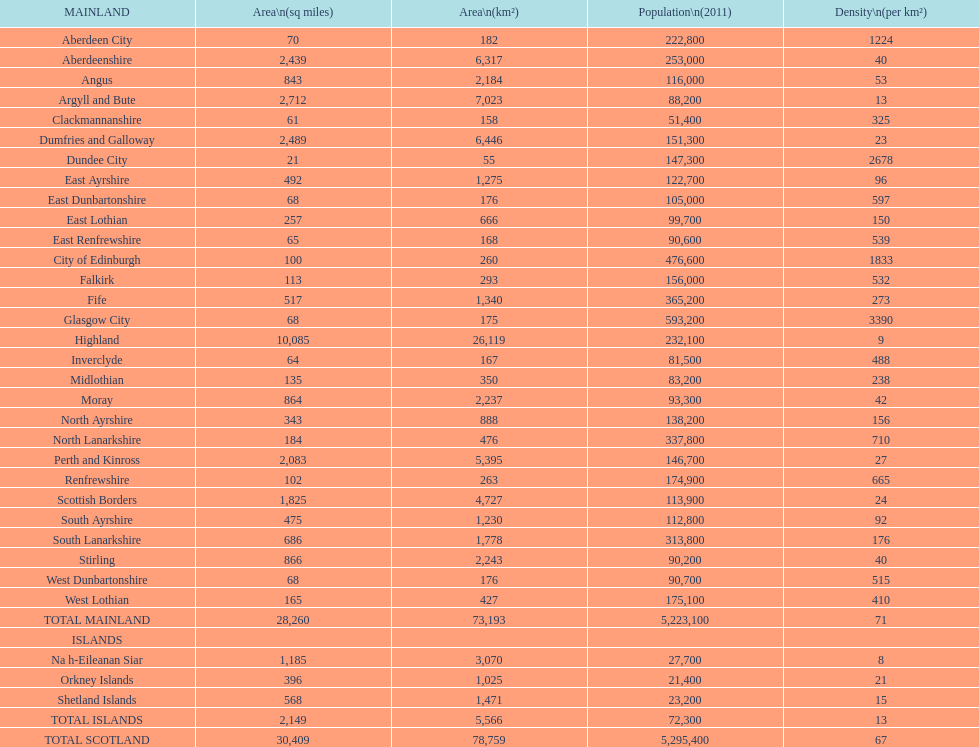Could you parse the entire table as a dict? {'header': ['MAINLAND', 'Area\\n(sq miles)', 'Area\\n(km²)', 'Population\\n(2011)', 'Density\\n(per km²)'], 'rows': [['Aberdeen City', '70', '182', '222,800', '1224'], ['Aberdeenshire', '2,439', '6,317', '253,000', '40'], ['Angus', '843', '2,184', '116,000', '53'], ['Argyll and Bute', '2,712', '7,023', '88,200', '13'], ['Clackmannanshire', '61', '158', '51,400', '325'], ['Dumfries and Galloway', '2,489', '6,446', '151,300', '23'], ['Dundee City', '21', '55', '147,300', '2678'], ['East Ayrshire', '492', '1,275', '122,700', '96'], ['East Dunbartonshire', '68', '176', '105,000', '597'], ['East Lothian', '257', '666', '99,700', '150'], ['East Renfrewshire', '65', '168', '90,600', '539'], ['City of Edinburgh', '100', '260', '476,600', '1833'], ['Falkirk', '113', '293', '156,000', '532'], ['Fife', '517', '1,340', '365,200', '273'], ['Glasgow City', '68', '175', '593,200', '3390'], ['Highland', '10,085', '26,119', '232,100', '9'], ['Inverclyde', '64', '167', '81,500', '488'], ['Midlothian', '135', '350', '83,200', '238'], ['Moray', '864', '2,237', '93,300', '42'], ['North Ayrshire', '343', '888', '138,200', '156'], ['North Lanarkshire', '184', '476', '337,800', '710'], ['Perth and Kinross', '2,083', '5,395', '146,700', '27'], ['Renfrewshire', '102', '263', '174,900', '665'], ['Scottish Borders', '1,825', '4,727', '113,900', '24'], ['South Ayrshire', '475', '1,230', '112,800', '92'], ['South Lanarkshire', '686', '1,778', '313,800', '176'], ['Stirling', '866', '2,243', '90,200', '40'], ['West Dunbartonshire', '68', '176', '90,700', '515'], ['West Lothian', '165', '427', '175,100', '410'], ['TOTAL MAINLAND', '28,260', '73,193', '5,223,100', '71'], ['ISLANDS', '', '', '', ''], ['Na h-Eileanan Siar', '1,185', '3,070', '27,700', '8'], ['Orkney Islands', '396', '1,025', '21,400', '21'], ['Shetland Islands', '568', '1,471', '23,200', '15'], ['TOTAL ISLANDS', '2,149', '5,566', '72,300', '13'], ['TOTAL SCOTLAND', '30,409', '78,759', '5,295,400', '67']]} What is the difference in square miles between angus and fife? 326. 